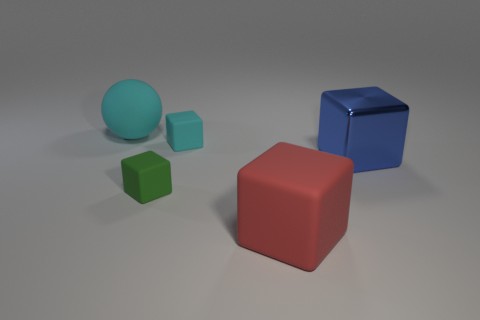Subtract all purple cubes. Subtract all blue balls. How many cubes are left? 4 Add 4 small things. How many objects exist? 9 Subtract all spheres. How many objects are left? 4 Add 3 tiny green blocks. How many tiny green blocks are left? 4 Add 2 big cyan rubber spheres. How many big cyan rubber spheres exist? 3 Subtract 0 red balls. How many objects are left? 5 Subtract all big metal cubes. Subtract all large spheres. How many objects are left? 3 